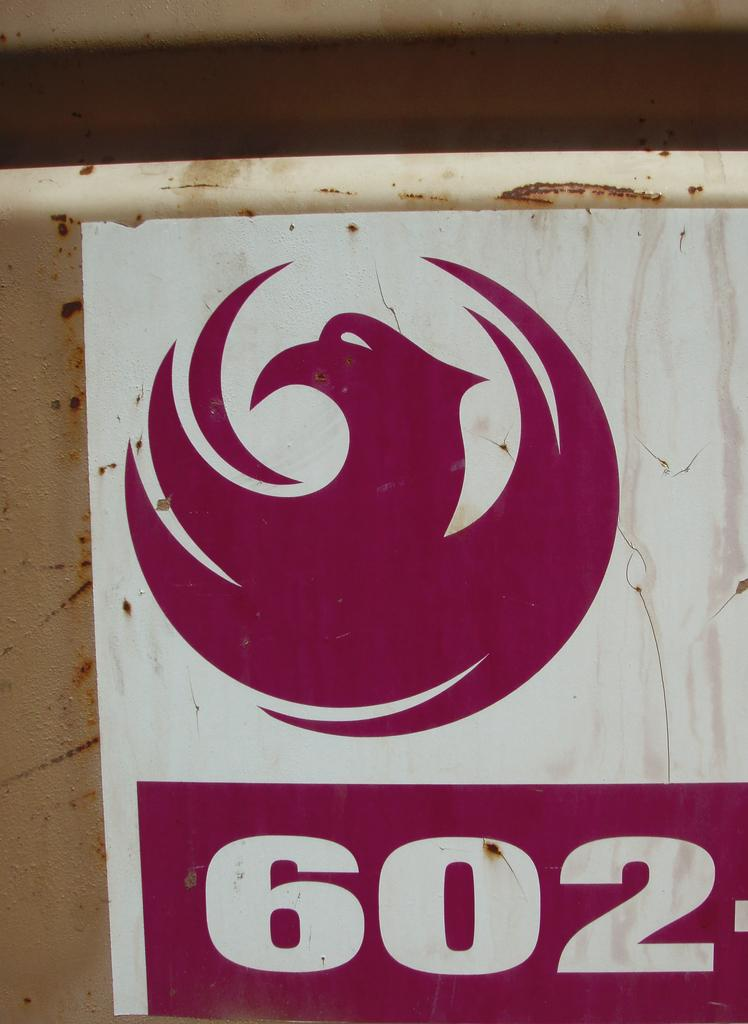<image>
Write a terse but informative summary of the picture. A banner has a bird logo on it and a phone number which begins with 602. 